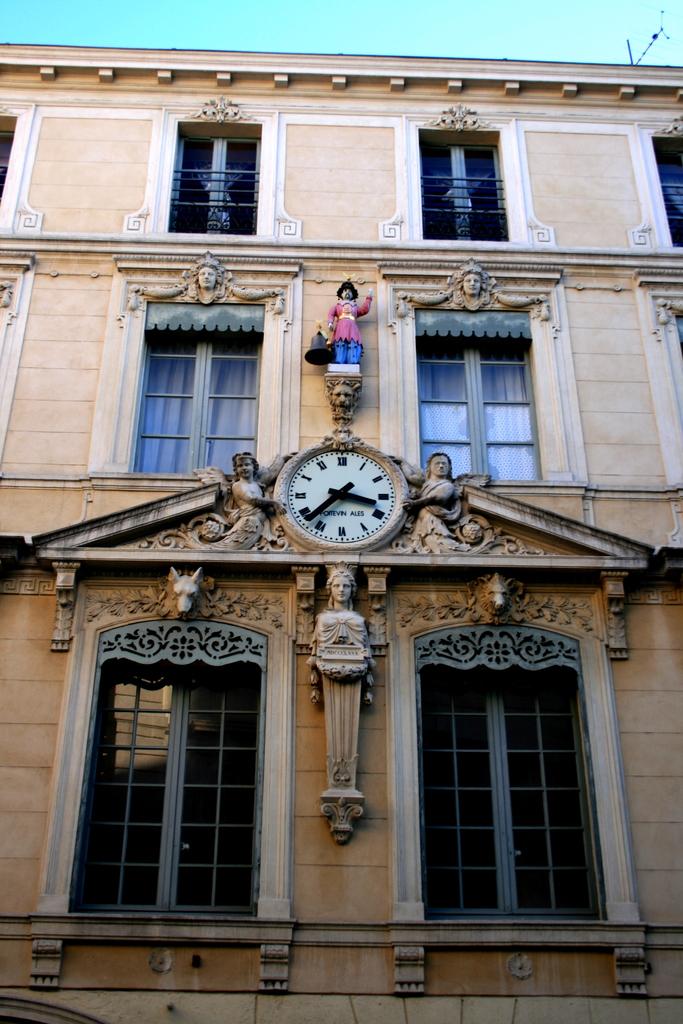What times is on the clock?
Offer a very short reply. 3:38. What number is the big hand on ?
Provide a short and direct response. 8. 